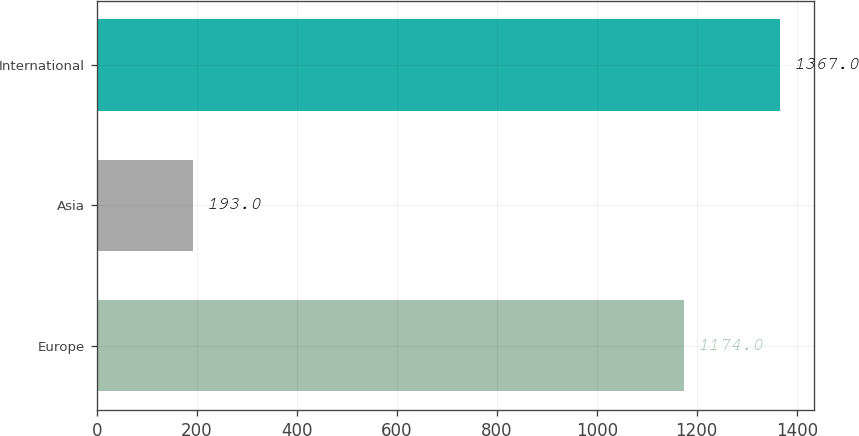Convert chart to OTSL. <chart><loc_0><loc_0><loc_500><loc_500><bar_chart><fcel>Europe<fcel>Asia<fcel>International<nl><fcel>1174<fcel>193<fcel>1367<nl></chart> 